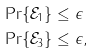Convert formula to latex. <formula><loc_0><loc_0><loc_500><loc_500>\Pr \{ \mathcal { E } _ { 1 } \} & \leq \epsilon \\ \Pr \{ \mathcal { E } _ { 3 } \} & \leq \epsilon ,</formula> 